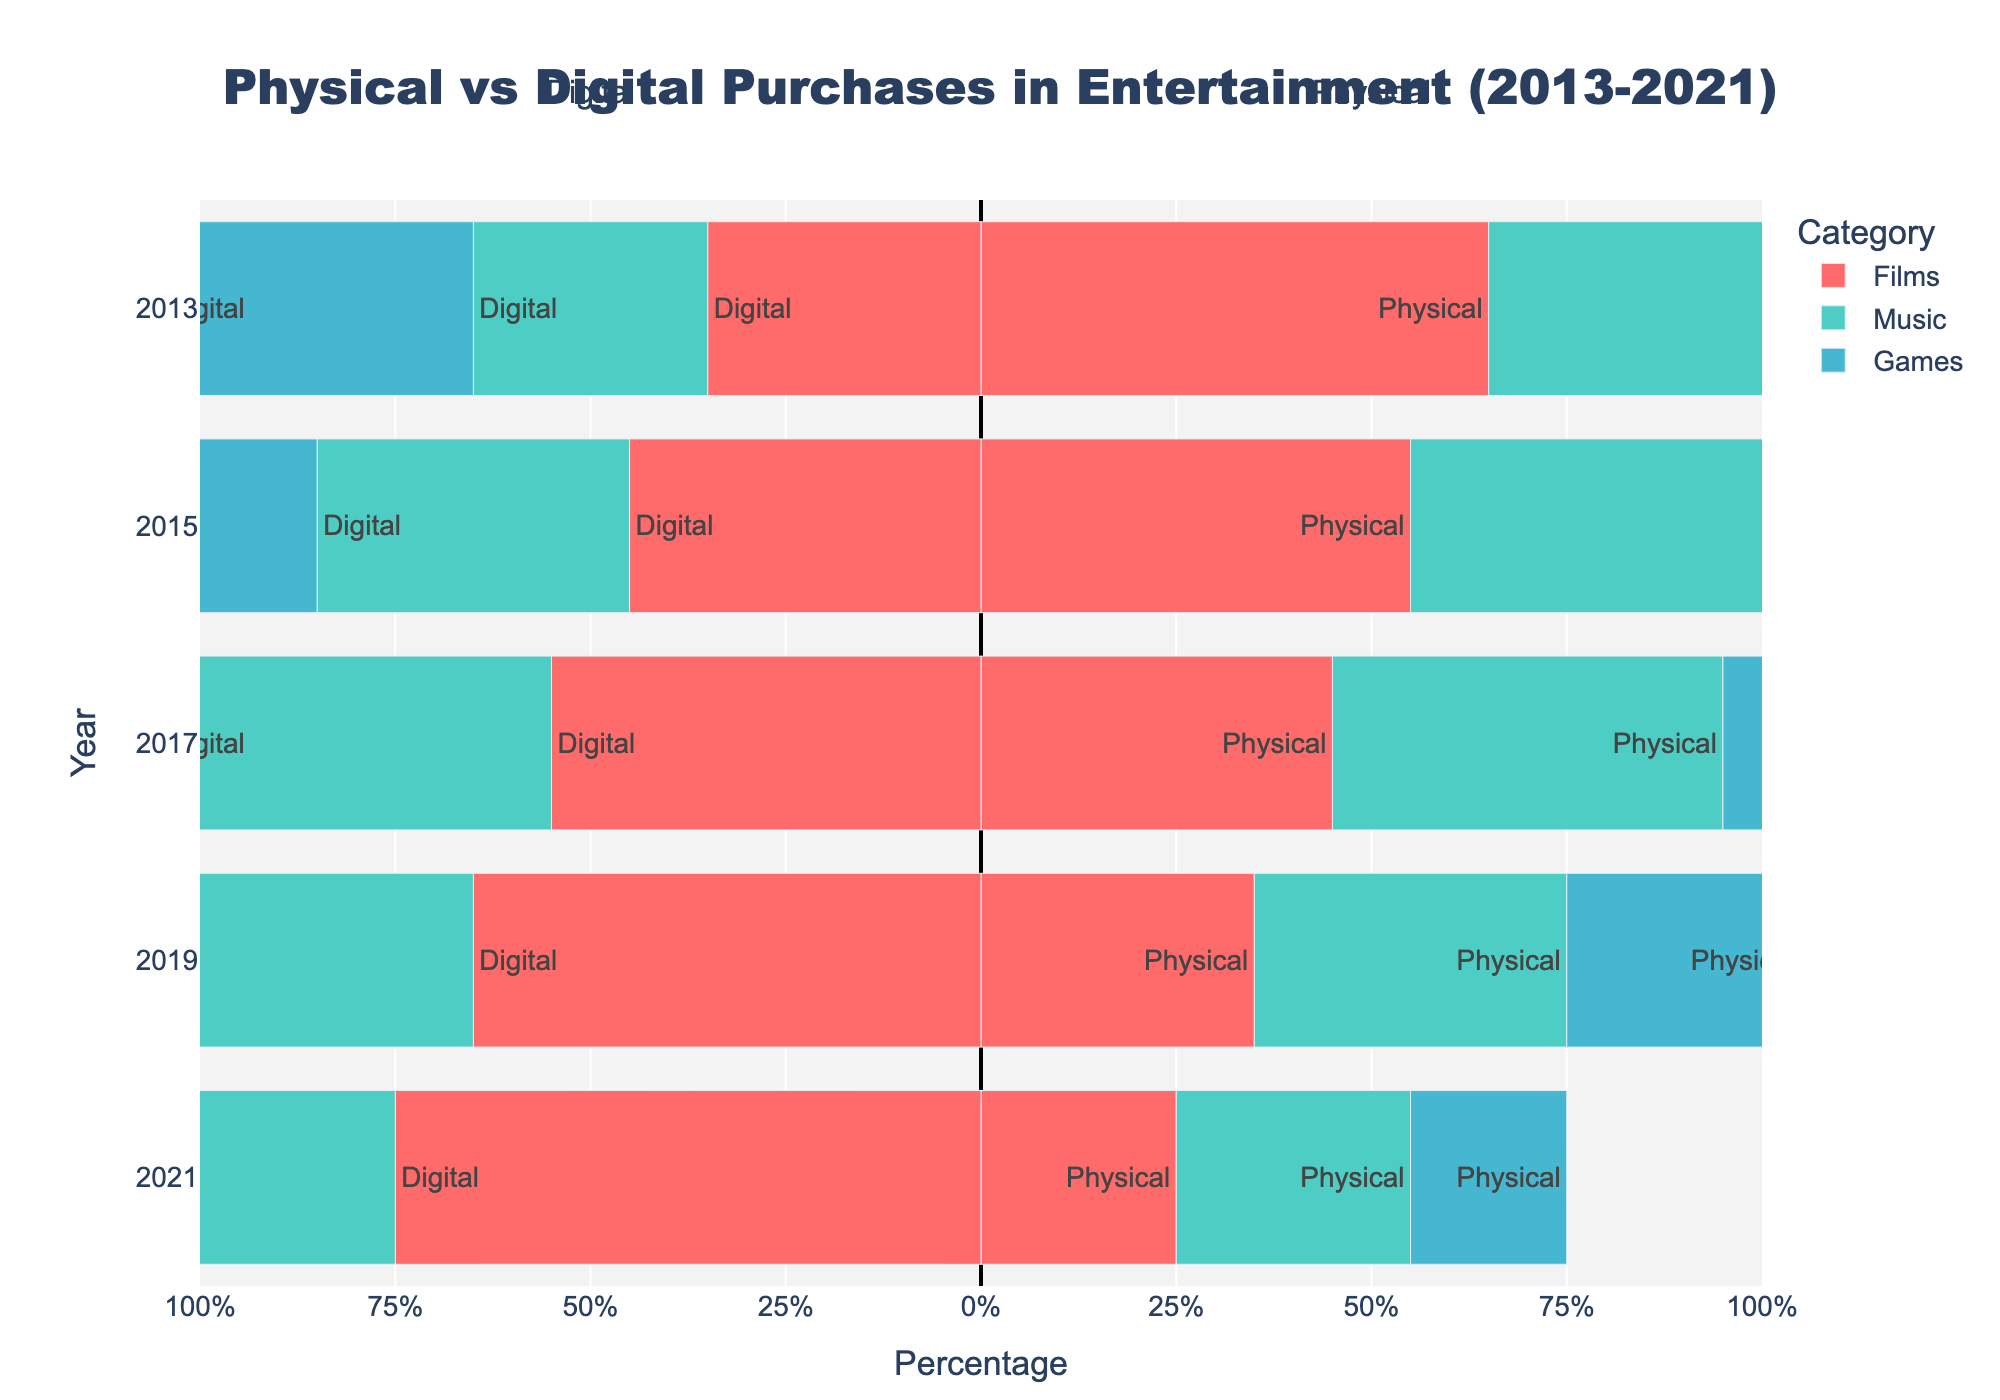How did the percentage of digital music purchases change from 2013 to 2021? The figure shows the percentage of digital music purchases increasing from 30% in 2013 to 70% in 2021.
Answer: Increased by 40% In which year did digital game purchases surpass physical game purchases? By examining the bars for games, digital purchases surpass physical purchases in 2017 when digital reached 60% and physical dropped to 40%.
Answer: 2017 For which entertainment category did physical purchases remain the highest throughout 2013? In 2013, physical purchases for music were at 70%, higher than films (65%) and games (60%).
Answer: Music What is the difference in the percentage of physical film purchases between 2013 and 2021? In 2013, physical film purchases were at 65%, and in 2021 it dropped to 25%. The difference is 65% - 25%.
Answer: 40% How did the trend of physical purchases for films change from 2013 to 2021? The percentage of physical film purchases consistently decreased from 65% in 2013 to 25% in 2021, as depicted by the shrinking red bars for films over the years.
Answer: Decreased steadily Which category had the highest digital purchase percentage in 2021? In 2021, the digital purchase percentage for games was 80%, which is higher than films (75%) and music (70%).
Answer: Games Compare the change in digital purchases between 2013 and 2021 for music and games. In 2013, digital purchases for music increased from 30% to 70%, while games increased from 40% to 80%. The change for music is 40% and for games is 40%.
Answer: Music: 40%, Games: 40% Which category saw the largest increase in digital purchases from 2017 to 2019? Digital film purchases increased from 55% in 2017 to 65% in 2019, music from 50% to 60%, and games from 60% to 70%. The largest increase was films at 10%.
Answer: Films How did the proportion of physical and digital purchases for films change between 2017 and 2019? In 2017, films had 45% physical and 55% digital. By 2019, physical dropped to 35% and digital rose to 65%.
Answer: Physical decreased, digital increased Which bar represents the highest percentage in digital purchases, and which category and year does it correspond to? The longest bar in the negative side (digital) is for games in 2021, indicating an 80% digital purchase rate.
Answer: Games, 2021 